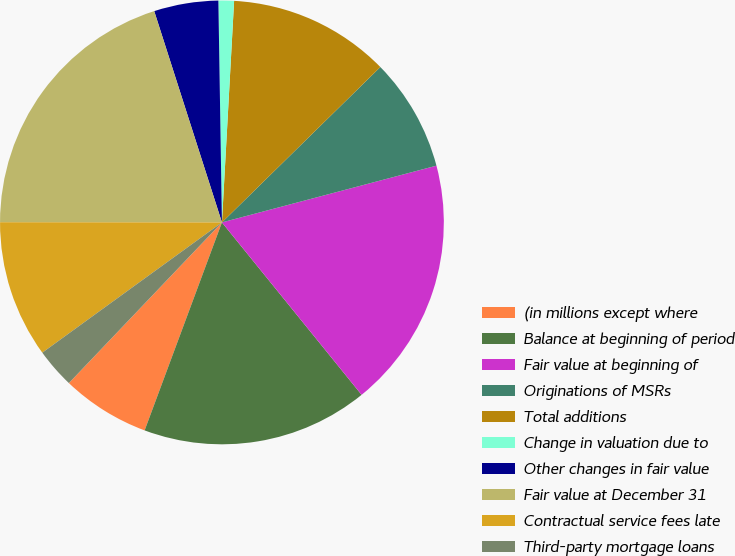Convert chart to OTSL. <chart><loc_0><loc_0><loc_500><loc_500><pie_chart><fcel>(in millions except where<fcel>Balance at beginning of period<fcel>Fair value at beginning of<fcel>Originations of MSRs<fcel>Total additions<fcel>Change in valuation due to<fcel>Other changes in fair value<fcel>Fair value at December 31<fcel>Contractual service fees late<fcel>Third-party mortgage loans<nl><fcel>6.45%<fcel>16.5%<fcel>18.28%<fcel>8.23%<fcel>11.78%<fcel>1.13%<fcel>4.68%<fcel>20.05%<fcel>10.0%<fcel>2.9%<nl></chart> 